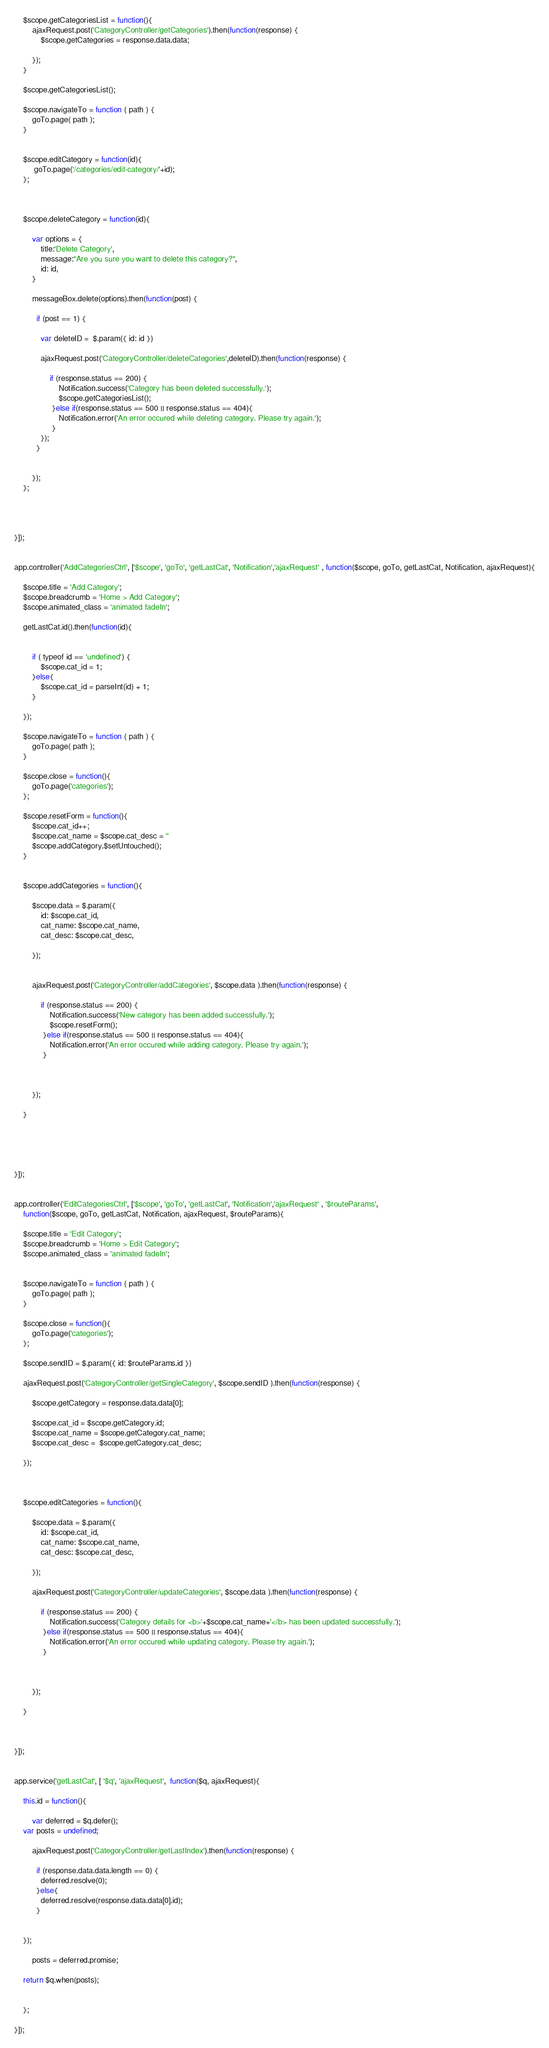Convert code to text. <code><loc_0><loc_0><loc_500><loc_500><_JavaScript_>

 	$scope.getCategoriesList = function(){
  		ajaxRequest.post('CategoryController/getCategories').then(function(response) {
	        $scope.getCategories = response.data.data;  
 
	    });
  	}

  	$scope.getCategoriesList();

  	$scope.navigateTo = function ( path ) {
        goTo.page( path );
    }


    $scope.editCategory = function(id){
    	 goTo.page('/categories/edit-category/'+id);
    };


   
    $scope.deleteCategory = function(id){

        var options = {
            title:'Delete Category',
            message:"Are you sure you want to delete this category?", 
            id: id,
        }

        messageBox.delete(options).then(function(post) {

          if (post == 1) {

            var deleteID =  $.param({ id: id })

            ajaxRequest.post('CategoryController/deleteCategories',deleteID).then(function(response) {
                 
                if (response.status == 200) {
                    Notification.success('Category has been deleted successfully.');
                    $scope.getCategoriesList(); 
                 }else if(response.status == 500 || response.status == 404){
                    Notification.error('An error occured while deleting category. Please try again.'); 
                 } 
            });
          }


        });
    };




}]);


app.controller('AddCategoriesCtrl', ['$scope', 'goTo', 'getLastCat', 'Notification','ajaxRequest' , function($scope, goTo, getLastCat, Notification, ajaxRequest){

	$scope.title = 'Add Category';
  	$scope.breadcrumb = 'Home > Add Category'; 
  	$scope.animated_class = 'animated fadeIn';

  	getLastCat.id().then(function(id){
		 

		if ( typeof id == 'undefined') {
	        $scope.cat_id = 1;
	    }else{ 
	        $scope.cat_id = parseInt(id) + 1; 
	    }

	});

  	$scope.navigateTo = function ( path ) {
        goTo.page( path );
    }

    $scope.close = function(){
	    goTo.page('categories');
	};

	$scope.resetForm = function(){
		$scope.cat_id++;
		$scope.cat_name = $scope.cat_desc = ''
		$scope.addCategory.$setUntouched();
	}


    $scope.addCategories = function(){

    	$scope.data = $.param({ 
           	id: $scope.cat_id, 
            cat_name: $scope.cat_name, 
            cat_desc: $scope.cat_desc,  

        });


    	ajaxRequest.post('CategoryController/addCategories', $scope.data ).then(function(response) {

            if (response.status == 200) {
                Notification.success('New category has been added successfully.');
                $scope.resetForm();
             }else if(response.status == 500 || response.status == 404){
                Notification.error('An error occured while adding category. Please try again.'); 
             }

            
            
        });
        
    }

  	 
	


}]);


app.controller('EditCategoriesCtrl', ['$scope', 'goTo', 'getLastCat', 'Notification','ajaxRequest' , '$routeParams', 
	function($scope, goTo, getLastCat, Notification, ajaxRequest, $routeParams){

	$scope.title = 'Edit Category';
  	$scope.breadcrumb = 'Home > Edit Category'; 
  	$scope.animated_class = 'animated fadeIn';

  	 
  	$scope.navigateTo = function ( path ) {
        goTo.page( path );
    }

    $scope.close = function(){
	    goTo.page('categories');
	};

	$scope.sendID = $.param({ id: $routeParams.id })

	ajaxRequest.post('CategoryController/getSingleCategory', $scope.sendID ).then(function(response) {
	 
		$scope.getCategory = response.data.data[0];

		$scope.cat_id = $scope.getCategory.id;
        $scope.cat_name = $scope.getCategory.cat_name;
        $scope.cat_desc =  $scope.getCategory.cat_desc;

	});

	 

    $scope.editCategories = function(){

    	$scope.data = $.param({ 
           	id: $scope.cat_id, 
            cat_name: $scope.cat_name, 
            cat_desc: $scope.cat_desc,  

        });

    	ajaxRequest.post('CategoryController/updateCategories', $scope.data ).then(function(response) {

            if (response.status == 200) {
                Notification.success('Category details for <b>'+$scope.cat_name+'</b> has been updated successfully.');
             }else if(response.status == 500 || response.status == 404){
                Notification.error('An error occured while updating category. Please try again.'); 
             }

            
            
        });
        
    }

  	 

}]);


app.service('getLastCat', [ '$q', 'ajaxRequest',  function($q, ajaxRequest){

	this.id = function(){ 

		var deferred = $q.defer();
   	var posts = undefined;

		ajaxRequest.post('CategoryController/getLastIndex').then(function(response) { 

          if (response.data.data.length == 0) {
            deferred.resolve(0); 
          }else{  
            deferred.resolve(response.data.data[0].id); 
          }

        	 
    });

		posts = deferred.promise;   

    return $q.when(posts);

	     
	};

}]);


</code> 